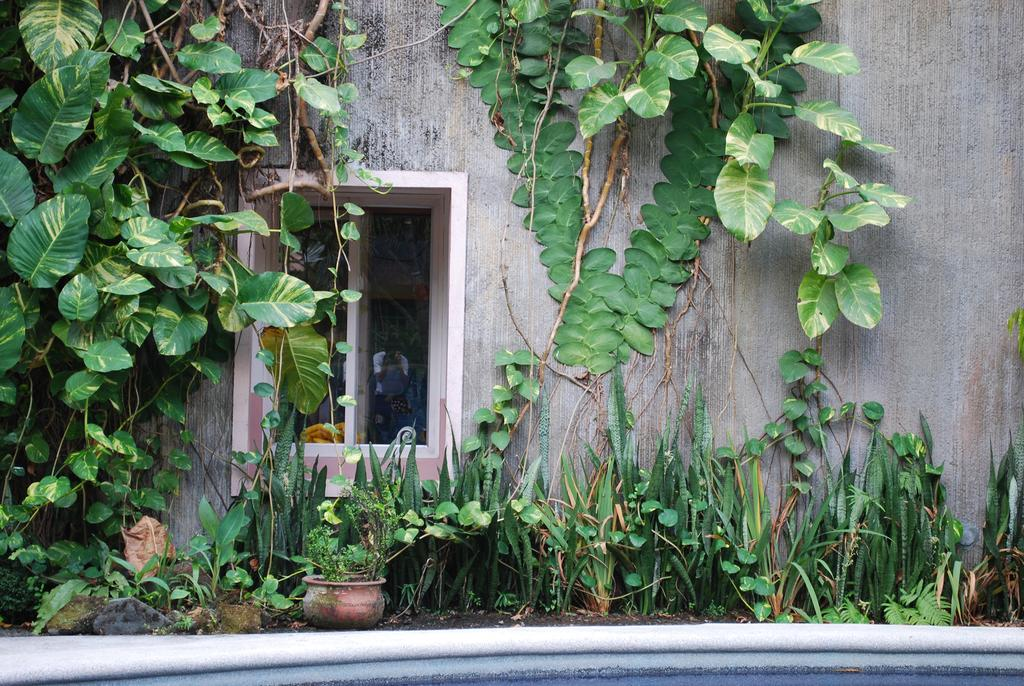What type of living organisms can be seen in the image? Plants can be seen in the image. What is the primary architectural feature visible in the image? There is a wall in the image. What allows natural light to enter the space in the image? There is a window in the image. Where is the stove located in the image? There is no stove present in the image. What type of playground equipment can be seen in the image? There is no playground equipment present in the image. 